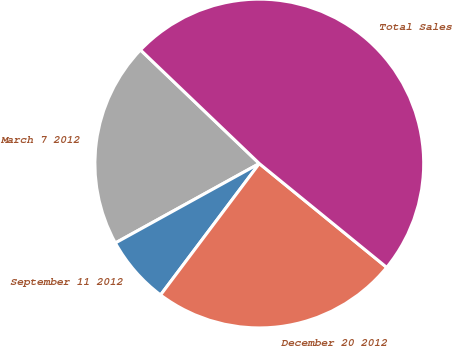Convert chart to OTSL. <chart><loc_0><loc_0><loc_500><loc_500><pie_chart><fcel>March 7 2012<fcel>September 11 2012<fcel>December 20 2012<fcel>Total Sales<nl><fcel>20.17%<fcel>6.72%<fcel>24.37%<fcel>48.74%<nl></chart> 